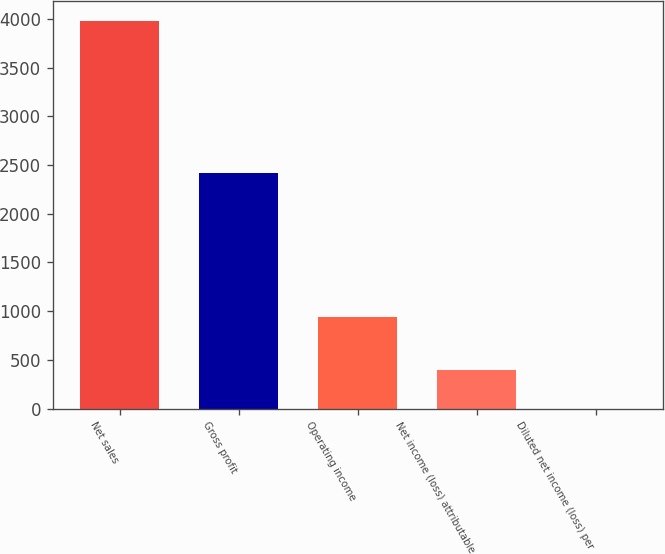Convert chart to OTSL. <chart><loc_0><loc_0><loc_500><loc_500><bar_chart><fcel>Net sales<fcel>Gross profit<fcel>Operating income<fcel>Net income (loss) attributable<fcel>Diluted net income (loss) per<nl><fcel>3980.8<fcel>2420.7<fcel>936.3<fcel>399.01<fcel>1.03<nl></chart> 